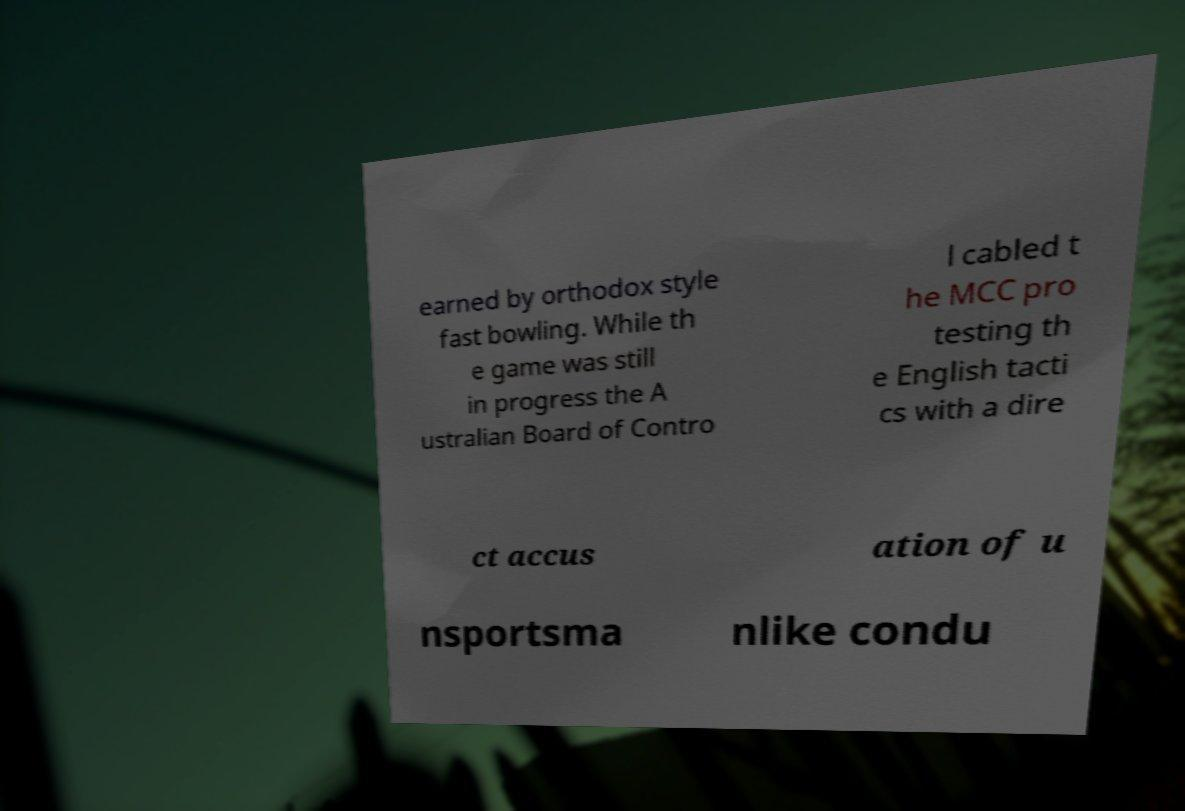Can you accurately transcribe the text from the provided image for me? earned by orthodox style fast bowling. While th e game was still in progress the A ustralian Board of Contro l cabled t he MCC pro testing th e English tacti cs with a dire ct accus ation of u nsportsma nlike condu 